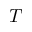Convert formula to latex. <formula><loc_0><loc_0><loc_500><loc_500>T</formula> 